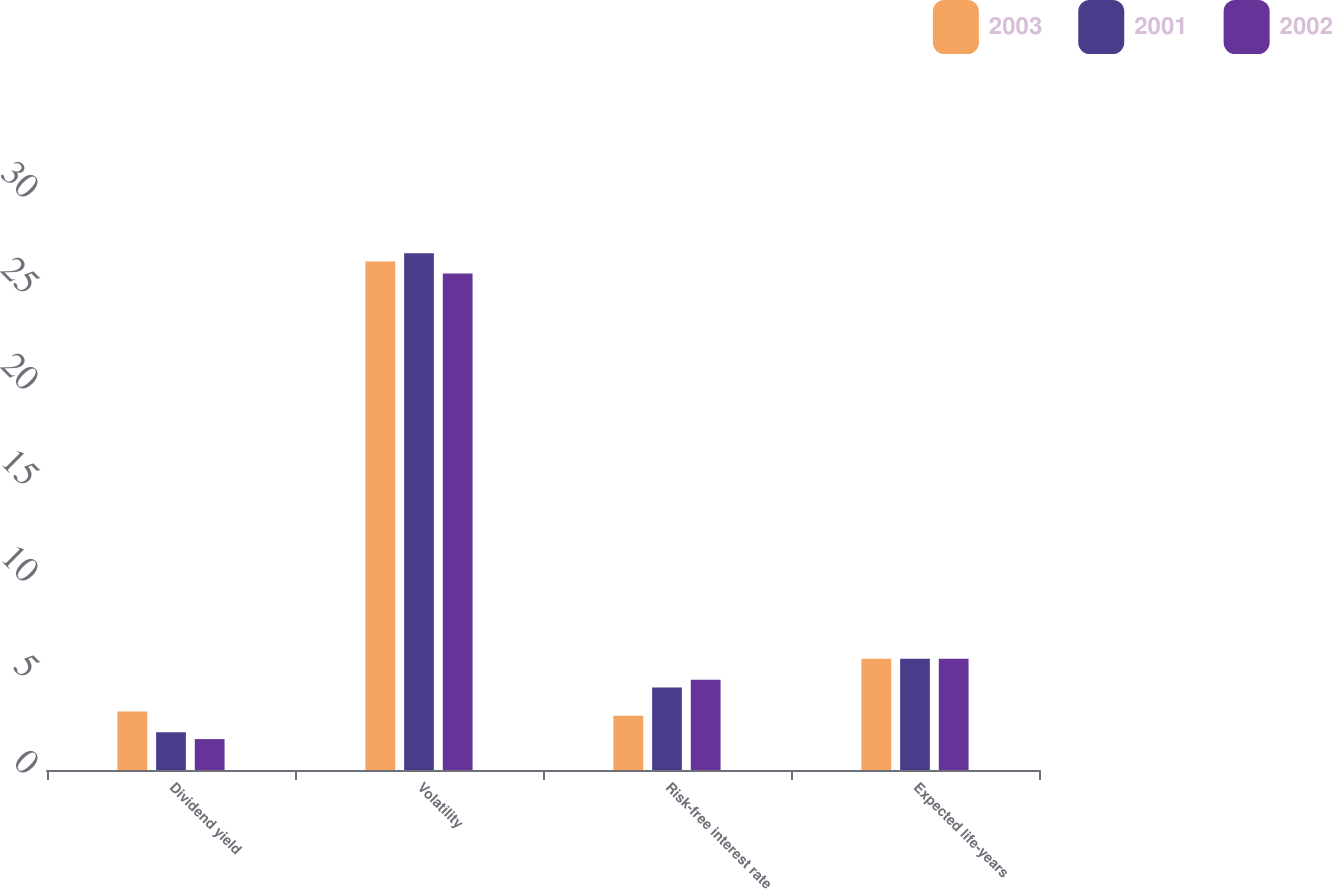Convert chart. <chart><loc_0><loc_0><loc_500><loc_500><stacked_bar_chart><ecel><fcel>Dividend yield<fcel>Volatility<fcel>Risk-free interest rate<fcel>Expected life-years<nl><fcel>2003<fcel>3.05<fcel>26.49<fcel>2.83<fcel>5.8<nl><fcel>2001<fcel>1.97<fcel>26.91<fcel>4.3<fcel>5.8<nl><fcel>2002<fcel>1.61<fcel>25.86<fcel>4.7<fcel>5.8<nl></chart> 